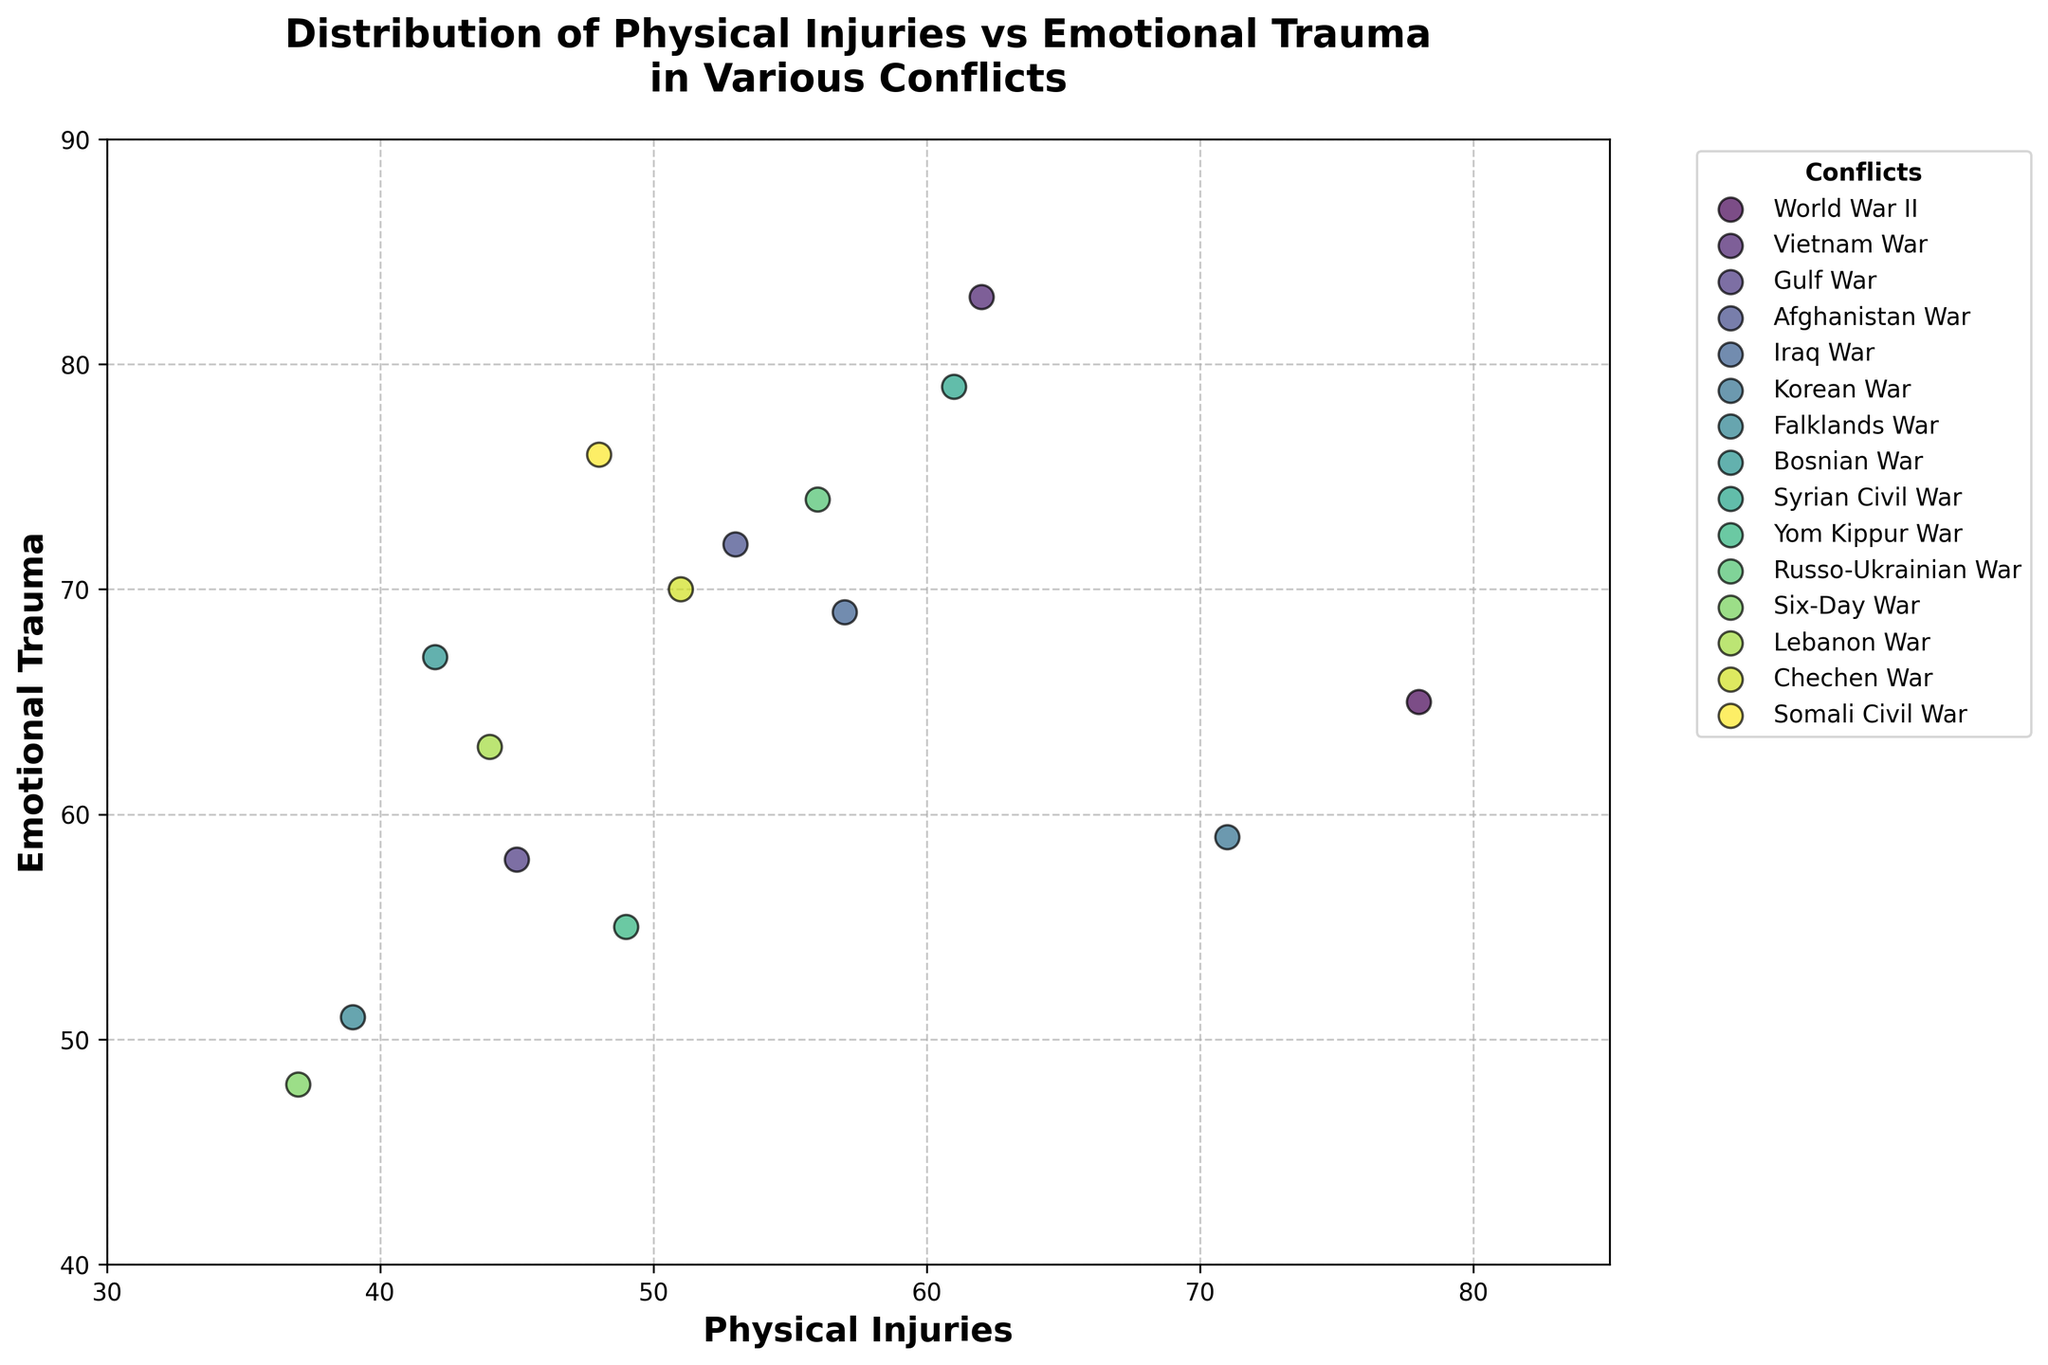What is the title of the figure? The title of the figure is usually found at the top, and it provides a summary of what the figure is about. In this case, the title is "Distribution of Physical Injuries vs Emotional Trauma in Various Conflicts".
Answer: Distribution of Physical Injuries vs Emotional Trauma in Various Conflicts Which conflict has the highest reported emotional trauma? To answer this, we look for the data point on the scatter plot with the highest y-axis value, which represents emotional trauma. The highest point is for the Vietnam War.
Answer: Vietnam War How many conflicts reported physical injuries between 50 and 60? We need to count the data points that fall between 50 and 60 on the x-axis (Physical Injuries). These conflicts are the Iraq War, Russo-Ukrainian War, and Chechen War.
Answer: 3 Which wars have higher emotional trauma than physical injuries? For this question, we need to find the data points where the y-axis value (Emotional Trauma) is greater than the x-axis value (Physical Injuries). These conflicts include Vietnam War, Afghanistan War, Syrian Civil War, Russo-Ukrainian War, Chechen War, and Somali Civil War.
Answer: Vietnam War, Afghanistan War, Syrian Civil War, Russo-Ukrainian War, Chechen War, Somali Civil War What is the difference in emotional trauma between the Vietnam War and the Korean War? We need to subtract the emotional trauma values for the Korean War (59) from the Vietnam War (83). The result is 83 - 59 = 24.
Answer: 24 What is the median value of physical injuries across all conflicts? To find the median, we need to list all physical injury values and find the middle one. The physical injuries values in ascending order are 37, 39, 42, 44, 45, 48, 49, 51, 53, 56, 57, 61, 62, 71, and 78. The middle value, or median, is 51.
Answer: 51 Is there any conflict where the number of emotional traumas equals the number of physical injuries? To answer this, we look for any data point where the x-axis value equals the y-axis value. There is no such point on the scatter plot, so no conflict has equal counts.
Answer: No Which conflict has the lowest number of physical injuries, and what is the corresponding emotional trauma for that conflict? The point with the smallest x-axis value (Physical Injuries) represents the Six-Day War with 37 physical injuries and 48 emotional traumas.
Answer: Six-Day War; 48 emotional traumas 